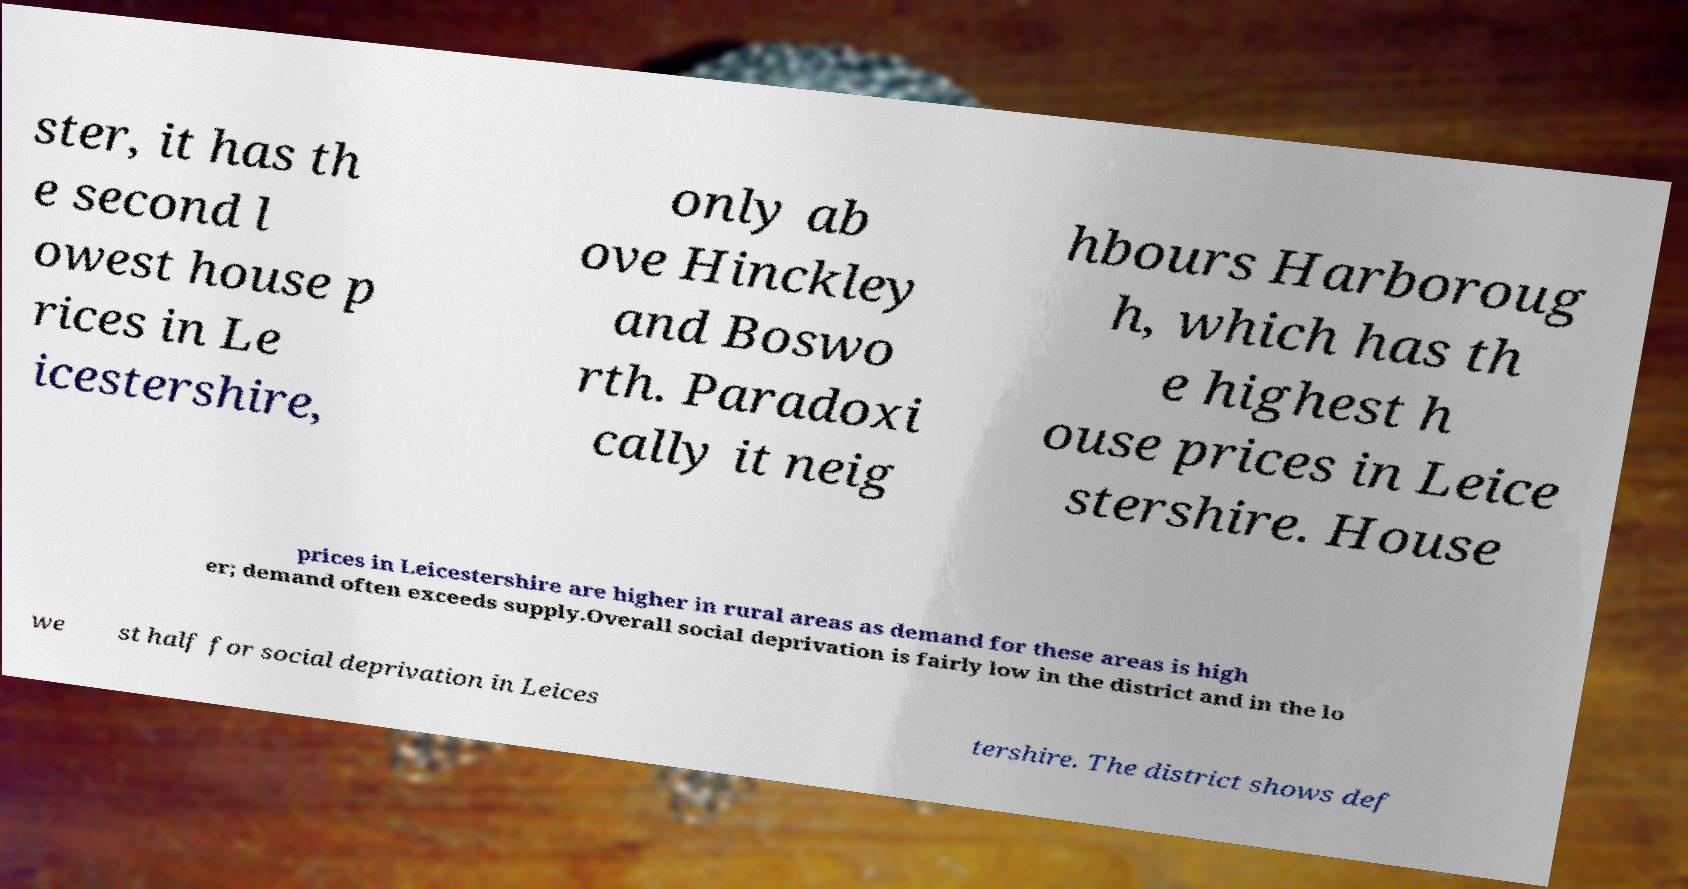Can you read and provide the text displayed in the image?This photo seems to have some interesting text. Can you extract and type it out for me? ster, it has th e second l owest house p rices in Le icestershire, only ab ove Hinckley and Boswo rth. Paradoxi cally it neig hbours Harboroug h, which has th e highest h ouse prices in Leice stershire. House prices in Leicestershire are higher in rural areas as demand for these areas is high er; demand often exceeds supply.Overall social deprivation is fairly low in the district and in the lo we st half for social deprivation in Leices tershire. The district shows def 